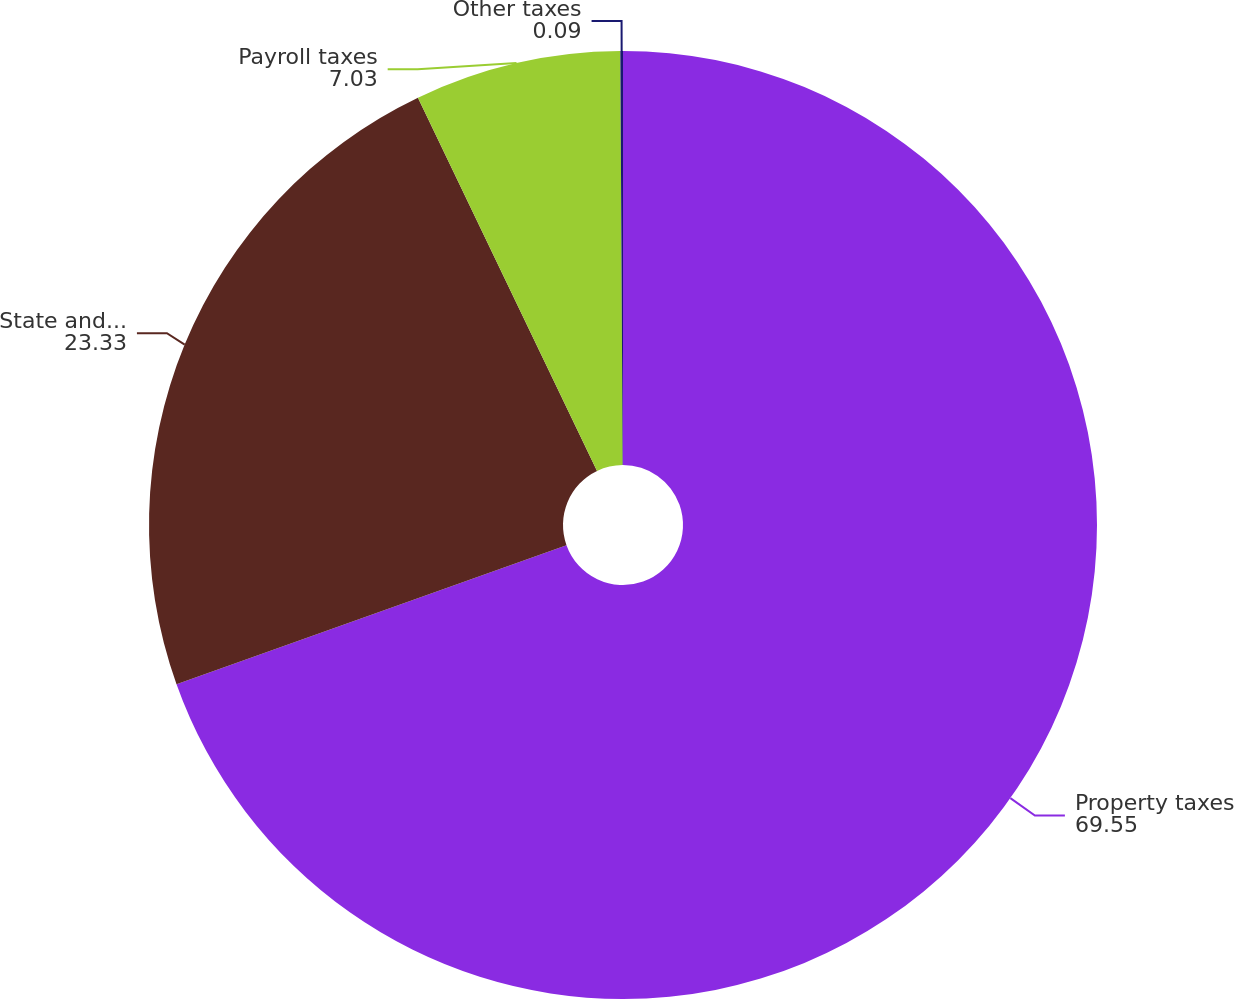<chart> <loc_0><loc_0><loc_500><loc_500><pie_chart><fcel>Property taxes<fcel>State and local taxes related<fcel>Payroll taxes<fcel>Other taxes<nl><fcel>69.55%<fcel>23.33%<fcel>7.03%<fcel>0.09%<nl></chart> 